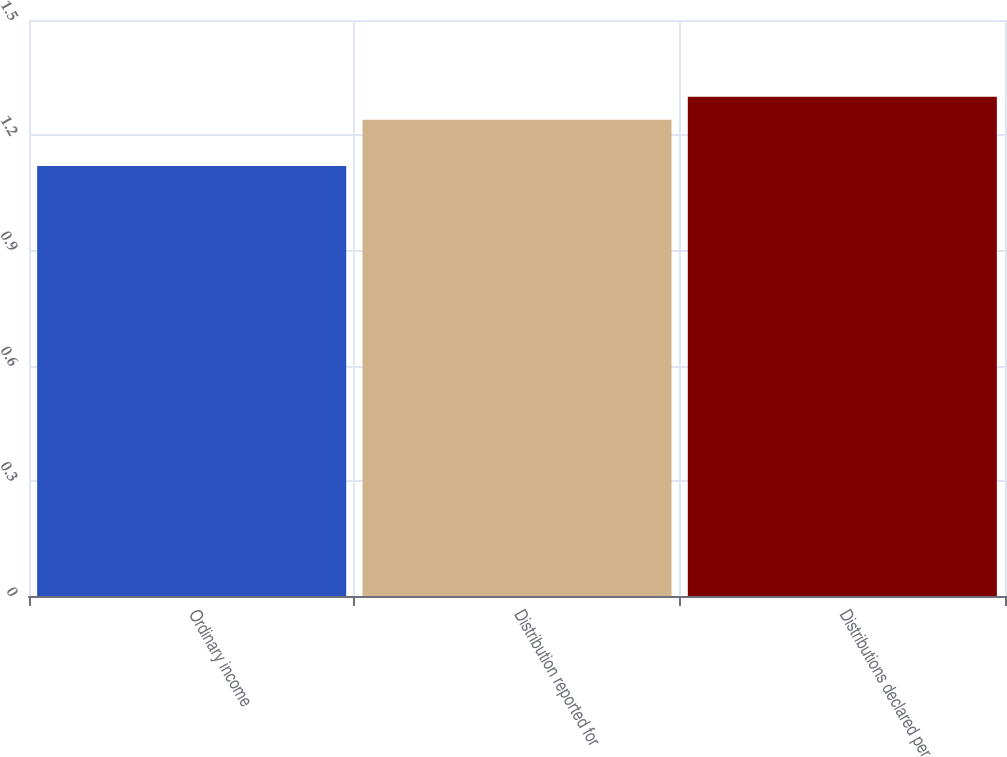<chart> <loc_0><loc_0><loc_500><loc_500><bar_chart><fcel>Ordinary income<fcel>Distribution reported for<fcel>Distributions declared per<nl><fcel>1.12<fcel>1.24<fcel>1.3<nl></chart> 